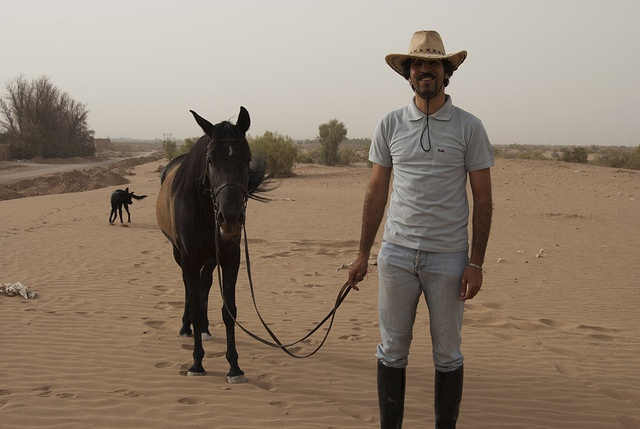Describe the objects in this image and their specific colors. I can see people in lightgray, gray, black, maroon, and darkgray tones, horse in lightgray, black, maroon, and gray tones, and dog in lightgray, black, gray, and tan tones in this image. 